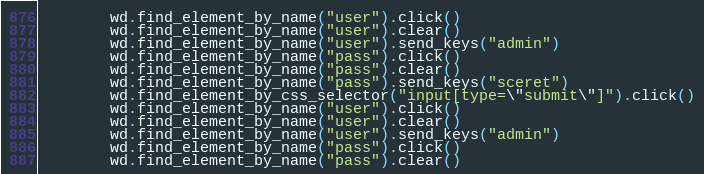Convert code to text. <code><loc_0><loc_0><loc_500><loc_500><_Python_>        wd.find_element_by_name("user").click()
        wd.find_element_by_name("user").clear()
        wd.find_element_by_name("user").send_keys("admin")
        wd.find_element_by_name("pass").click()
        wd.find_element_by_name("pass").clear()
        wd.find_element_by_name("pass").send_keys("sceret")
        wd.find_element_by_css_selector("input[type=\"submit\"]").click()
        wd.find_element_by_name("user").click()
        wd.find_element_by_name("user").clear()
        wd.find_element_by_name("user").send_keys("admin")
        wd.find_element_by_name("pass").click()
        wd.find_element_by_name("pass").clear()</code> 